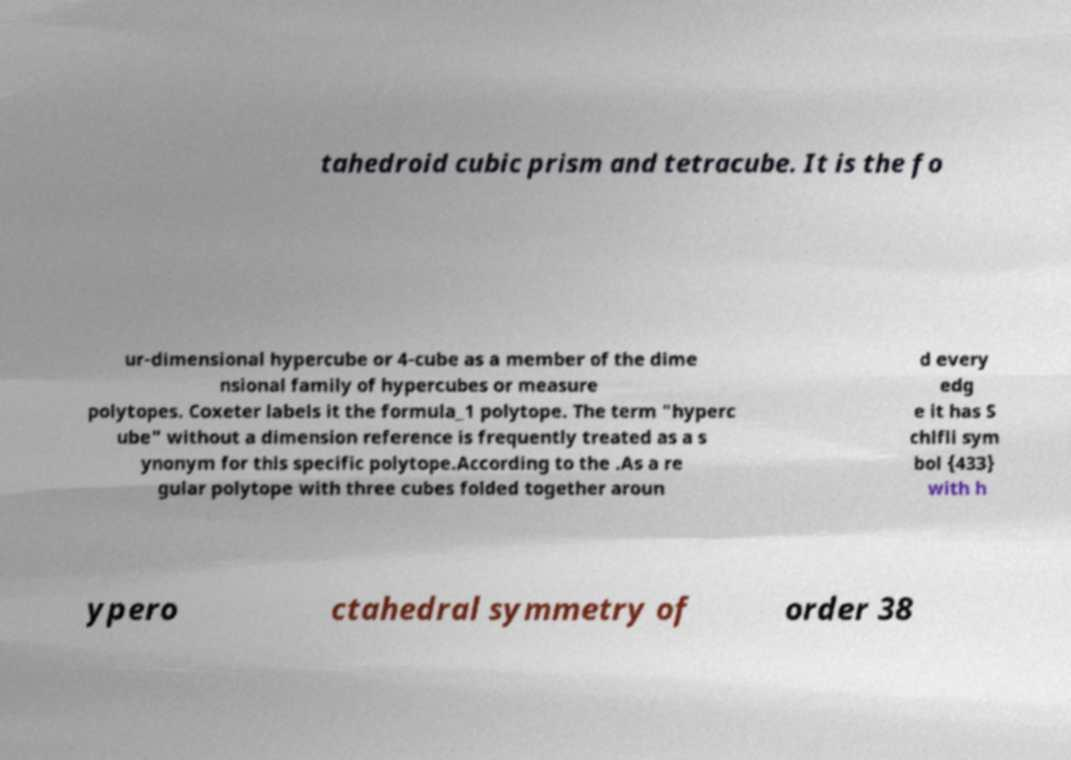There's text embedded in this image that I need extracted. Can you transcribe it verbatim? tahedroid cubic prism and tetracube. It is the fo ur-dimensional hypercube or 4-cube as a member of the dime nsional family of hypercubes or measure polytopes. Coxeter labels it the formula_1 polytope. The term "hyperc ube" without a dimension reference is frequently treated as a s ynonym for this specific polytope.According to the .As a re gular polytope with three cubes folded together aroun d every edg e it has S chlfli sym bol {433} with h ypero ctahedral symmetry of order 38 